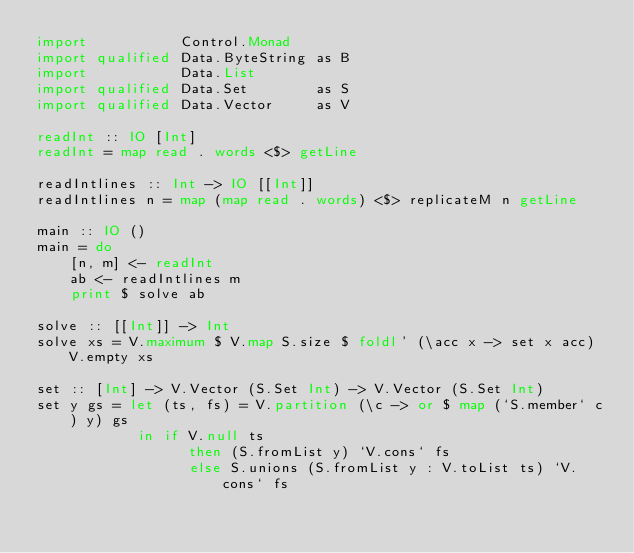Convert code to text. <code><loc_0><loc_0><loc_500><loc_500><_Haskell_>import           Control.Monad
import qualified Data.ByteString as B
import           Data.List
import qualified Data.Set        as S
import qualified Data.Vector     as V

readInt :: IO [Int]
readInt = map read . words <$> getLine

readIntlines :: Int -> IO [[Int]]
readIntlines n = map (map read . words) <$> replicateM n getLine

main :: IO ()
main = do
    [n, m] <- readInt
    ab <- readIntlines m
    print $ solve ab

solve :: [[Int]] -> Int
solve xs = V.maximum $ V.map S.size $ foldl' (\acc x -> set x acc) V.empty xs

set :: [Int] -> V.Vector (S.Set Int) -> V.Vector (S.Set Int)
set y gs = let (ts, fs) = V.partition (\c -> or $ map (`S.member` c) y) gs
            in if V.null ts
                  then (S.fromList y) `V.cons` fs
                  else S.unions (S.fromList y : V.toList ts) `V.cons` fs
</code> 